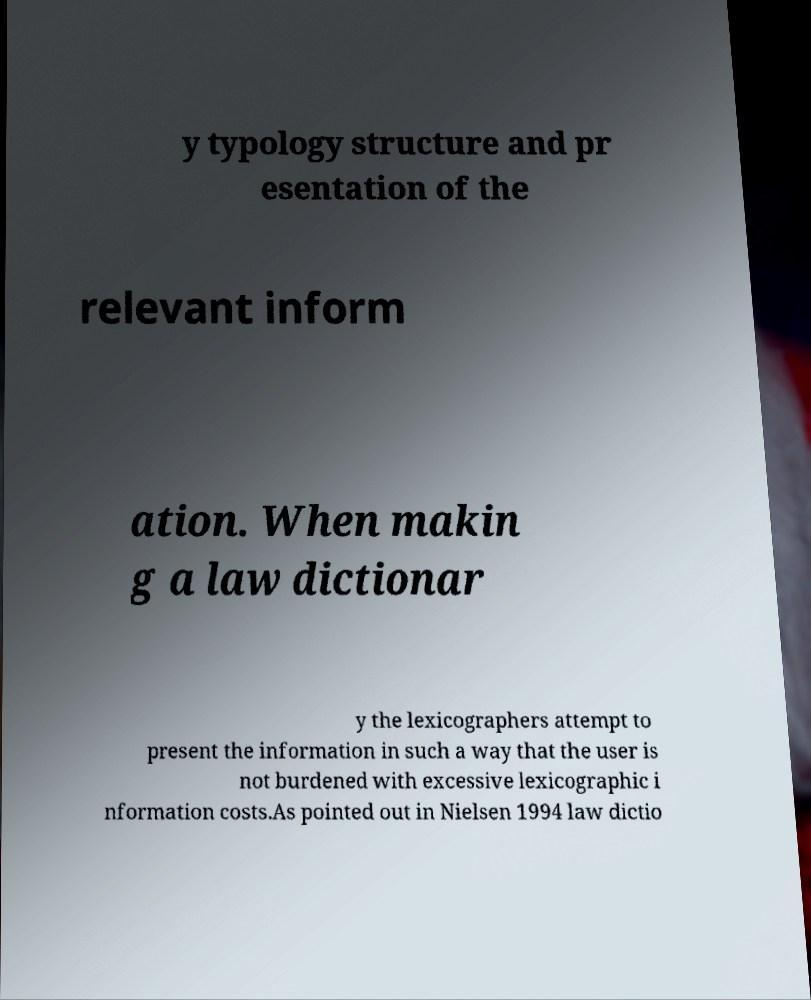Could you extract and type out the text from this image? y typology structure and pr esentation of the relevant inform ation. When makin g a law dictionar y the lexicographers attempt to present the information in such a way that the user is not burdened with excessive lexicographic i nformation costs.As pointed out in Nielsen 1994 law dictio 